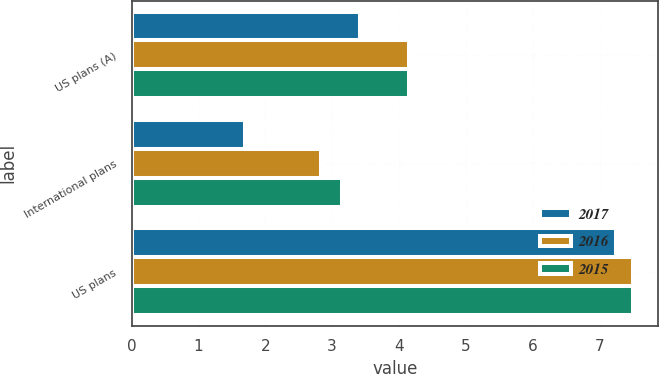Convert chart to OTSL. <chart><loc_0><loc_0><loc_500><loc_500><stacked_bar_chart><ecel><fcel>US plans (A)<fcel>International plans<fcel>US plans<nl><fcel>2017<fcel>3.42<fcel>1.7<fcel>7.25<nl><fcel>2016<fcel>4.15<fcel>2.84<fcel>7.5<nl><fcel>2015<fcel>4.15<fcel>3.14<fcel>7.5<nl></chart> 